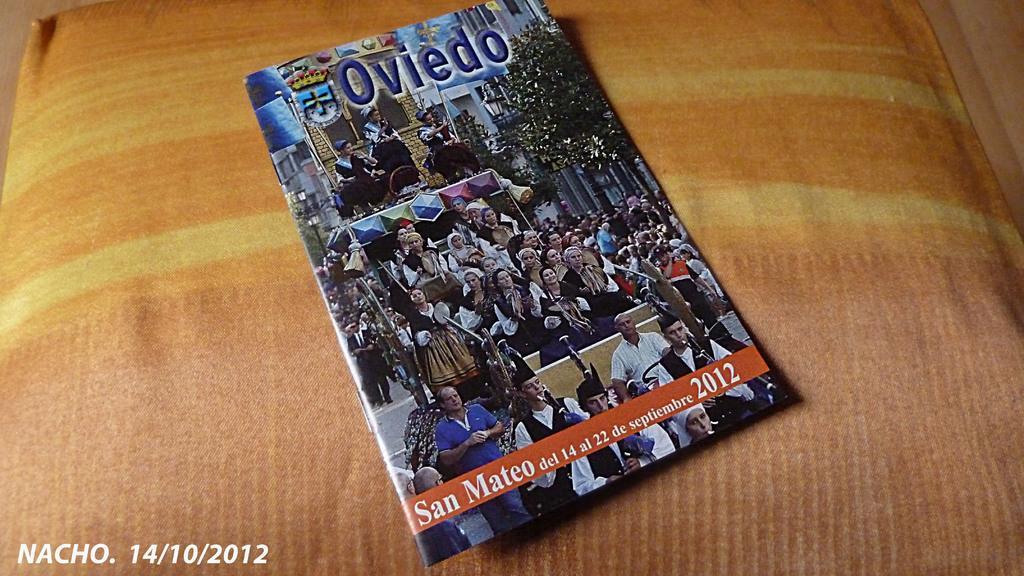Could you give a brief overview of what you see in this image? In this picture there is a book which is placed on a pillow in the center of the image. 